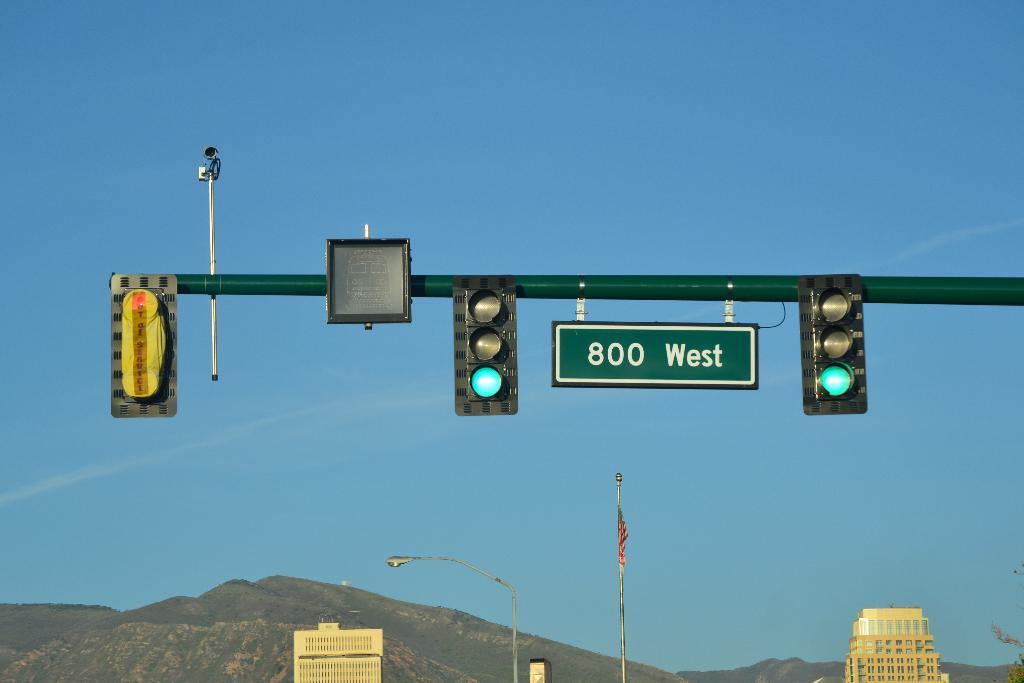What road is this?
Offer a very short reply. 800 west. What is the number of the road?
Ensure brevity in your answer.  800. 